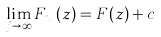Convert formula to latex. <formula><loc_0><loc_0><loc_500><loc_500>\lim _ { j \to \infty } F _ { n _ { j } } ( z ) = F ( z ) + c</formula> 